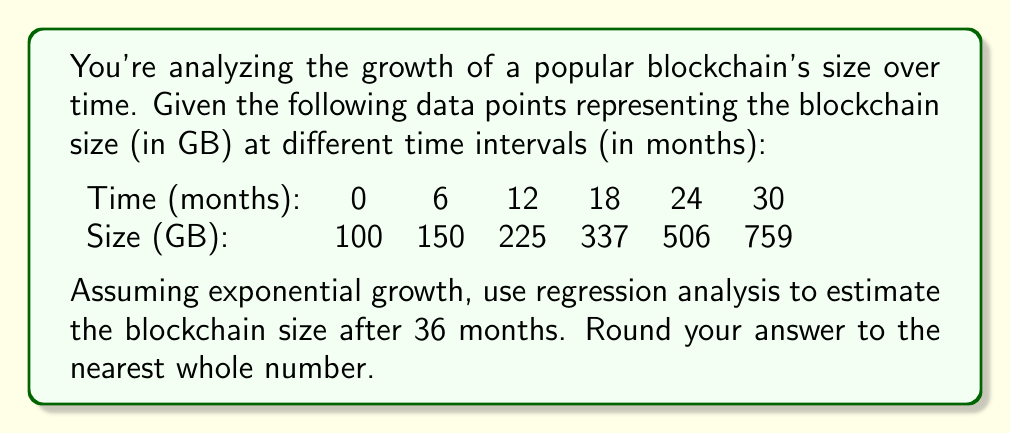What is the answer to this math problem? To estimate the blockchain size using exponential regression, we'll follow these steps:

1) The exponential growth model has the form:
   $$ y = ae^{bt} $$
   where $y$ is the size, $t$ is the time, and $a$ and $b$ are constants we need to determine.

2) Taking the natural log of both sides:
   $$ \ln(y) = \ln(a) + bt $$

3) This transforms our problem into a linear regression problem:
   $$ Y = A + bX $$
   where $Y = \ln(y)$, $A = \ln(a)$, and $X = t$

4) Calculate $X$, $Y$, $X^2$, $XY$ for each data point:

   | $X$ | $y$  | $Y = \ln(y)$ | $X^2$ | $XY$     |
   |-----|------|--------------|-------|----------|
   | 0   | 100  | 4.6052       | 0     | 0        |
   | 6   | 150  | 5.0106       | 36    | 30.0636  |
   | 12  | 225  | 5.4161       | 144   | 64.9932  |
   | 18  | 337  | 5.8201       | 324   | 104.7618 |
   | 24  | 506  | 6.2265       | 576   | 149.4360 |
   | 30  | 759  | 6.6320       | 900   | 198.9600 |

5) Sum up the columns:
   $\sum X = 90$, $\sum Y = 33.7105$, $\sum X^2 = 1980$, $\sum XY = 548.2146$, $n = 6$

6) Use the following formulas to calculate $b$ and $A$:
   $$ b = \frac{n\sum XY - \sum X \sum Y}{n\sum X^2 - (\sum X)^2} $$
   $$ A = \frac{\sum Y - b\sum X}{n} $$

7) Plugging in the values:
   $$ b = \frac{6(548.2146) - 90(33.7105)}{6(1980) - 90^2} = 0.0677 $$
   $$ A = \frac{33.7105 - 0.0677(90)}{6} = 4.6052 $$

8) Now we have $Y = 4.6052 + 0.0677X$

9) To get back to our original exponential form:
   $$ y = e^{4.6052} \cdot e^{0.0677t} = 100 \cdot e^{0.0677t} $$

10) To estimate the size at 36 months, plug in $t = 36$:
    $$ y = 100 \cdot e^{0.0677 \cdot 36} = 1138.83 $$

11) Rounding to the nearest whole number: 1139 GB
Answer: 1139 GB 